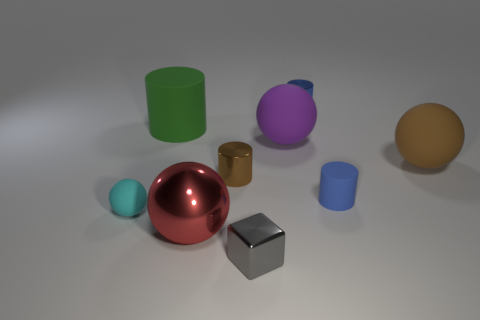The matte thing that is to the right of the tiny cyan rubber ball and to the left of the red object is what color?
Provide a succinct answer. Green. There is a brown object left of the small gray metallic object; what is it made of?
Provide a succinct answer. Metal. The brown matte object has what size?
Offer a very short reply. Large. What number of gray objects are small shiny cylinders or big shiny cylinders?
Provide a short and direct response. 0. What size is the matte sphere that is on the right side of the tiny matte object that is to the right of the tiny matte sphere?
Offer a very short reply. Large. Do the large cylinder and the tiny metallic thing behind the brown ball have the same color?
Provide a succinct answer. No. What number of other things are the same material as the large green cylinder?
Keep it short and to the point. 4. There is a big purple object that is the same material as the big brown sphere; what is its shape?
Ensure brevity in your answer.  Sphere. Are there any other things that have the same color as the metallic sphere?
Keep it short and to the point. No. What size is the metal object that is the same color as the tiny rubber cylinder?
Give a very brief answer. Small. 